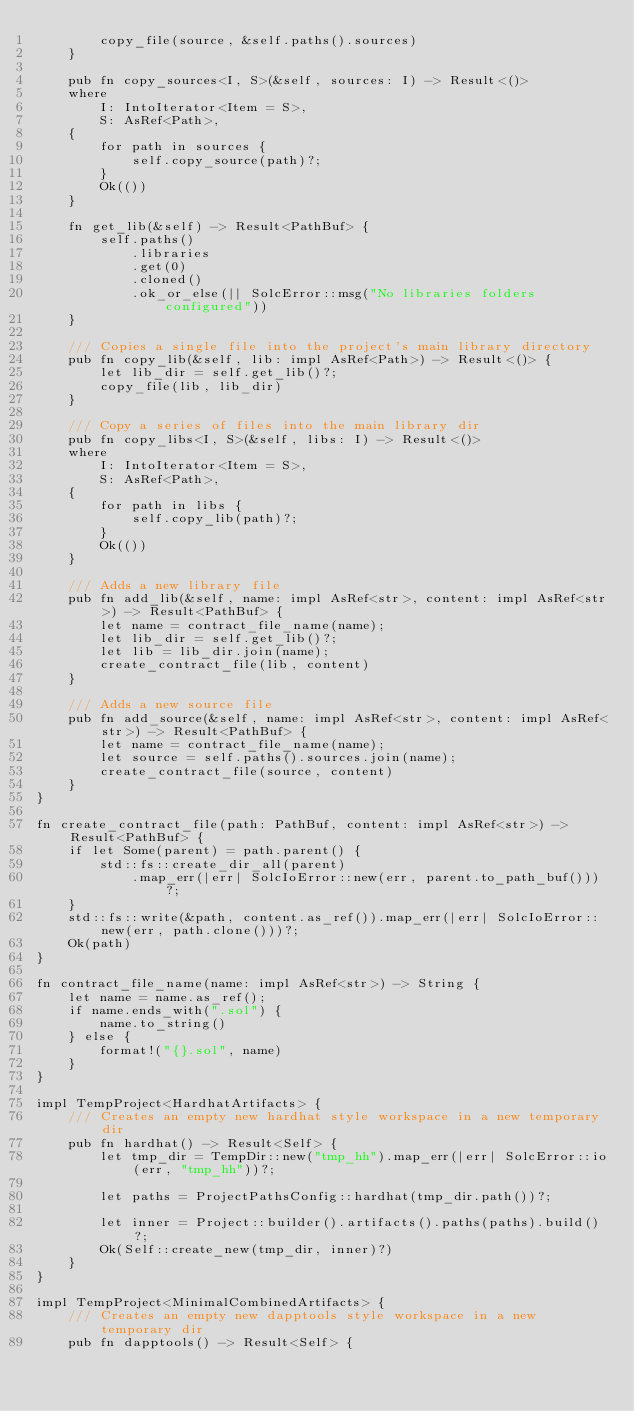Convert code to text. <code><loc_0><loc_0><loc_500><loc_500><_Rust_>        copy_file(source, &self.paths().sources)
    }

    pub fn copy_sources<I, S>(&self, sources: I) -> Result<()>
    where
        I: IntoIterator<Item = S>,
        S: AsRef<Path>,
    {
        for path in sources {
            self.copy_source(path)?;
        }
        Ok(())
    }

    fn get_lib(&self) -> Result<PathBuf> {
        self.paths()
            .libraries
            .get(0)
            .cloned()
            .ok_or_else(|| SolcError::msg("No libraries folders configured"))
    }

    /// Copies a single file into the project's main library directory
    pub fn copy_lib(&self, lib: impl AsRef<Path>) -> Result<()> {
        let lib_dir = self.get_lib()?;
        copy_file(lib, lib_dir)
    }

    /// Copy a series of files into the main library dir
    pub fn copy_libs<I, S>(&self, libs: I) -> Result<()>
    where
        I: IntoIterator<Item = S>,
        S: AsRef<Path>,
    {
        for path in libs {
            self.copy_lib(path)?;
        }
        Ok(())
    }

    /// Adds a new library file
    pub fn add_lib(&self, name: impl AsRef<str>, content: impl AsRef<str>) -> Result<PathBuf> {
        let name = contract_file_name(name);
        let lib_dir = self.get_lib()?;
        let lib = lib_dir.join(name);
        create_contract_file(lib, content)
    }

    /// Adds a new source file
    pub fn add_source(&self, name: impl AsRef<str>, content: impl AsRef<str>) -> Result<PathBuf> {
        let name = contract_file_name(name);
        let source = self.paths().sources.join(name);
        create_contract_file(source, content)
    }
}

fn create_contract_file(path: PathBuf, content: impl AsRef<str>) -> Result<PathBuf> {
    if let Some(parent) = path.parent() {
        std::fs::create_dir_all(parent)
            .map_err(|err| SolcIoError::new(err, parent.to_path_buf()))?;
    }
    std::fs::write(&path, content.as_ref()).map_err(|err| SolcIoError::new(err, path.clone()))?;
    Ok(path)
}

fn contract_file_name(name: impl AsRef<str>) -> String {
    let name = name.as_ref();
    if name.ends_with(".sol") {
        name.to_string()
    } else {
        format!("{}.sol", name)
    }
}

impl TempProject<HardhatArtifacts> {
    /// Creates an empty new hardhat style workspace in a new temporary dir
    pub fn hardhat() -> Result<Self> {
        let tmp_dir = TempDir::new("tmp_hh").map_err(|err| SolcError::io(err, "tmp_hh"))?;

        let paths = ProjectPathsConfig::hardhat(tmp_dir.path())?;

        let inner = Project::builder().artifacts().paths(paths).build()?;
        Ok(Self::create_new(tmp_dir, inner)?)
    }
}

impl TempProject<MinimalCombinedArtifacts> {
    /// Creates an empty new dapptools style workspace in a new temporary dir
    pub fn dapptools() -> Result<Self> {</code> 